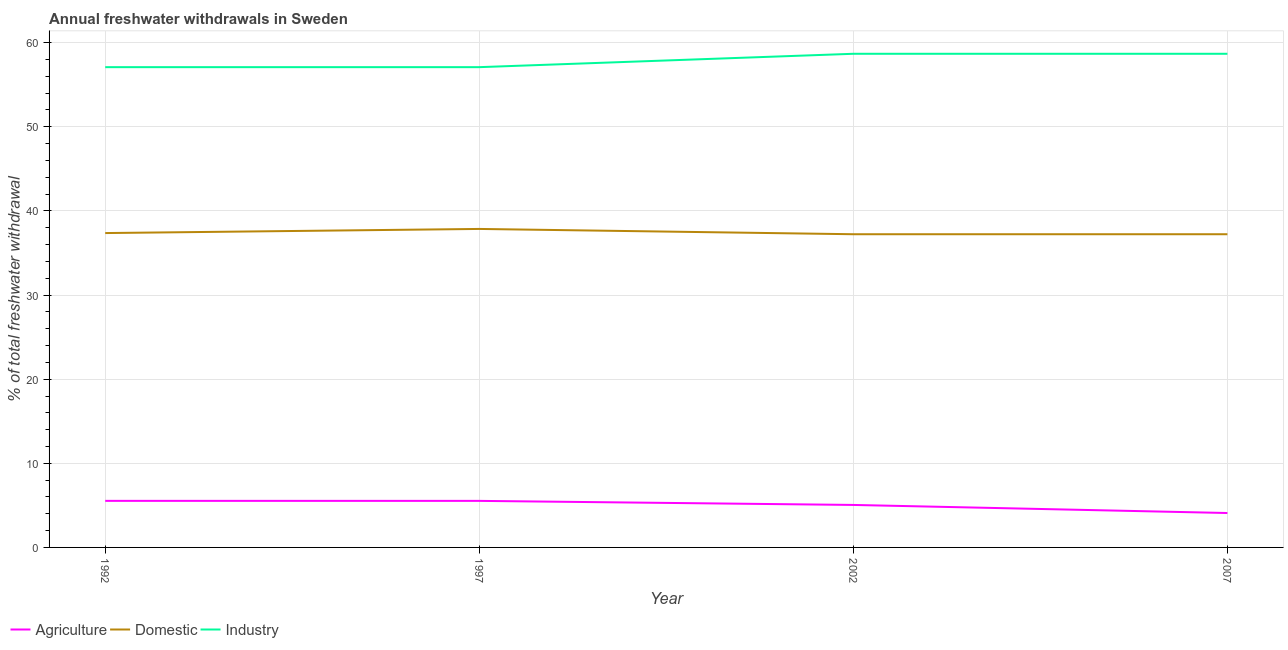How many different coloured lines are there?
Offer a very short reply. 3. Does the line corresponding to percentage of freshwater withdrawal for domestic purposes intersect with the line corresponding to percentage of freshwater withdrawal for industry?
Ensure brevity in your answer.  No. What is the percentage of freshwater withdrawal for agriculture in 1992?
Ensure brevity in your answer.  5.54. Across all years, what is the maximum percentage of freshwater withdrawal for domestic purposes?
Offer a very short reply. 37.86. Across all years, what is the minimum percentage of freshwater withdrawal for industry?
Your response must be concise. 57.09. In which year was the percentage of freshwater withdrawal for domestic purposes maximum?
Your response must be concise. 1997. What is the total percentage of freshwater withdrawal for industry in the graph?
Give a very brief answer. 231.54. What is the difference between the percentage of freshwater withdrawal for industry in 1992 and that in 2007?
Keep it short and to the point. -1.59. What is the difference between the percentage of freshwater withdrawal for industry in 2007 and the percentage of freshwater withdrawal for domestic purposes in 1992?
Your answer should be very brief. 21.31. What is the average percentage of freshwater withdrawal for domestic purposes per year?
Provide a short and direct response. 37.42. In the year 2002, what is the difference between the percentage of freshwater withdrawal for domestic purposes and percentage of freshwater withdrawal for agriculture?
Offer a very short reply. 32.18. What is the ratio of the percentage of freshwater withdrawal for agriculture in 1992 to that in 1997?
Your response must be concise. 1. What is the difference between the highest and the second highest percentage of freshwater withdrawal for domestic purposes?
Your answer should be very brief. 0.49. What is the difference between the highest and the lowest percentage of freshwater withdrawal for domestic purposes?
Your answer should be very brief. 0.63. Is the sum of the percentage of freshwater withdrawal for industry in 1992 and 1997 greater than the maximum percentage of freshwater withdrawal for agriculture across all years?
Your answer should be very brief. Yes. Does the percentage of freshwater withdrawal for domestic purposes monotonically increase over the years?
Ensure brevity in your answer.  No. Is the percentage of freshwater withdrawal for agriculture strictly greater than the percentage of freshwater withdrawal for industry over the years?
Provide a short and direct response. No. Is the percentage of freshwater withdrawal for agriculture strictly less than the percentage of freshwater withdrawal for domestic purposes over the years?
Provide a succinct answer. Yes. How many lines are there?
Give a very brief answer. 3. How many years are there in the graph?
Keep it short and to the point. 4. What is the difference between two consecutive major ticks on the Y-axis?
Make the answer very short. 10. Are the values on the major ticks of Y-axis written in scientific E-notation?
Your response must be concise. No. How many legend labels are there?
Provide a short and direct response. 3. How are the legend labels stacked?
Your response must be concise. Horizontal. What is the title of the graph?
Your answer should be compact. Annual freshwater withdrawals in Sweden. Does "Social Insurance" appear as one of the legend labels in the graph?
Keep it short and to the point. No. What is the label or title of the X-axis?
Ensure brevity in your answer.  Year. What is the label or title of the Y-axis?
Your answer should be compact. % of total freshwater withdrawal. What is the % of total freshwater withdrawal in Agriculture in 1992?
Your answer should be compact. 5.54. What is the % of total freshwater withdrawal of Domestic in 1992?
Your answer should be very brief. 37.37. What is the % of total freshwater withdrawal of Industry in 1992?
Make the answer very short. 57.09. What is the % of total freshwater withdrawal of Agriculture in 1997?
Your answer should be very brief. 5.53. What is the % of total freshwater withdrawal of Domestic in 1997?
Your response must be concise. 37.86. What is the % of total freshwater withdrawal in Industry in 1997?
Offer a terse response. 57.09. What is the % of total freshwater withdrawal of Agriculture in 2002?
Make the answer very short. 5.05. What is the % of total freshwater withdrawal of Domestic in 2002?
Your answer should be compact. 37.23. What is the % of total freshwater withdrawal of Industry in 2002?
Your response must be concise. 58.68. What is the % of total freshwater withdrawal of Agriculture in 2007?
Keep it short and to the point. 4.09. What is the % of total freshwater withdrawal in Domestic in 2007?
Keep it short and to the point. 37.23. What is the % of total freshwater withdrawal in Industry in 2007?
Offer a very short reply. 58.68. Across all years, what is the maximum % of total freshwater withdrawal in Agriculture?
Provide a succinct answer. 5.54. Across all years, what is the maximum % of total freshwater withdrawal of Domestic?
Offer a terse response. 37.86. Across all years, what is the maximum % of total freshwater withdrawal in Industry?
Ensure brevity in your answer.  58.68. Across all years, what is the minimum % of total freshwater withdrawal in Agriculture?
Provide a short and direct response. 4.09. Across all years, what is the minimum % of total freshwater withdrawal of Domestic?
Offer a very short reply. 37.23. Across all years, what is the minimum % of total freshwater withdrawal in Industry?
Keep it short and to the point. 57.09. What is the total % of total freshwater withdrawal in Agriculture in the graph?
Provide a short and direct response. 20.21. What is the total % of total freshwater withdrawal in Domestic in the graph?
Offer a very short reply. 149.69. What is the total % of total freshwater withdrawal in Industry in the graph?
Offer a terse response. 231.54. What is the difference between the % of total freshwater withdrawal of Agriculture in 1992 and that in 1997?
Provide a succinct answer. 0. What is the difference between the % of total freshwater withdrawal in Domestic in 1992 and that in 1997?
Provide a short and direct response. -0.49. What is the difference between the % of total freshwater withdrawal in Industry in 1992 and that in 1997?
Provide a succinct answer. 0. What is the difference between the % of total freshwater withdrawal in Agriculture in 1992 and that in 2002?
Your answer should be compact. 0.48. What is the difference between the % of total freshwater withdrawal of Domestic in 1992 and that in 2002?
Offer a very short reply. 0.14. What is the difference between the % of total freshwater withdrawal of Industry in 1992 and that in 2002?
Keep it short and to the point. -1.59. What is the difference between the % of total freshwater withdrawal in Agriculture in 1992 and that in 2007?
Provide a succinct answer. 1.45. What is the difference between the % of total freshwater withdrawal in Domestic in 1992 and that in 2007?
Your answer should be compact. 0.14. What is the difference between the % of total freshwater withdrawal of Industry in 1992 and that in 2007?
Give a very brief answer. -1.59. What is the difference between the % of total freshwater withdrawal of Agriculture in 1997 and that in 2002?
Your answer should be very brief. 0.48. What is the difference between the % of total freshwater withdrawal in Domestic in 1997 and that in 2002?
Ensure brevity in your answer.  0.63. What is the difference between the % of total freshwater withdrawal of Industry in 1997 and that in 2002?
Give a very brief answer. -1.59. What is the difference between the % of total freshwater withdrawal of Agriculture in 1997 and that in 2007?
Provide a succinct answer. 1.44. What is the difference between the % of total freshwater withdrawal in Domestic in 1997 and that in 2007?
Your response must be concise. 0.63. What is the difference between the % of total freshwater withdrawal of Industry in 1997 and that in 2007?
Your response must be concise. -1.59. What is the difference between the % of total freshwater withdrawal of Agriculture in 2002 and that in 2007?
Ensure brevity in your answer.  0.96. What is the difference between the % of total freshwater withdrawal of Domestic in 2002 and that in 2007?
Provide a succinct answer. 0. What is the difference between the % of total freshwater withdrawal in Agriculture in 1992 and the % of total freshwater withdrawal in Domestic in 1997?
Keep it short and to the point. -32.32. What is the difference between the % of total freshwater withdrawal of Agriculture in 1992 and the % of total freshwater withdrawal of Industry in 1997?
Offer a terse response. -51.55. What is the difference between the % of total freshwater withdrawal of Domestic in 1992 and the % of total freshwater withdrawal of Industry in 1997?
Offer a terse response. -19.72. What is the difference between the % of total freshwater withdrawal in Agriculture in 1992 and the % of total freshwater withdrawal in Domestic in 2002?
Your answer should be compact. -31.69. What is the difference between the % of total freshwater withdrawal in Agriculture in 1992 and the % of total freshwater withdrawal in Industry in 2002?
Your response must be concise. -53.14. What is the difference between the % of total freshwater withdrawal in Domestic in 1992 and the % of total freshwater withdrawal in Industry in 2002?
Your response must be concise. -21.31. What is the difference between the % of total freshwater withdrawal in Agriculture in 1992 and the % of total freshwater withdrawal in Domestic in 2007?
Give a very brief answer. -31.69. What is the difference between the % of total freshwater withdrawal of Agriculture in 1992 and the % of total freshwater withdrawal of Industry in 2007?
Your response must be concise. -53.14. What is the difference between the % of total freshwater withdrawal of Domestic in 1992 and the % of total freshwater withdrawal of Industry in 2007?
Provide a succinct answer. -21.31. What is the difference between the % of total freshwater withdrawal of Agriculture in 1997 and the % of total freshwater withdrawal of Domestic in 2002?
Offer a terse response. -31.7. What is the difference between the % of total freshwater withdrawal of Agriculture in 1997 and the % of total freshwater withdrawal of Industry in 2002?
Your answer should be compact. -53.15. What is the difference between the % of total freshwater withdrawal in Domestic in 1997 and the % of total freshwater withdrawal in Industry in 2002?
Your answer should be compact. -20.82. What is the difference between the % of total freshwater withdrawal in Agriculture in 1997 and the % of total freshwater withdrawal in Domestic in 2007?
Give a very brief answer. -31.7. What is the difference between the % of total freshwater withdrawal in Agriculture in 1997 and the % of total freshwater withdrawal in Industry in 2007?
Offer a terse response. -53.15. What is the difference between the % of total freshwater withdrawal in Domestic in 1997 and the % of total freshwater withdrawal in Industry in 2007?
Your answer should be very brief. -20.82. What is the difference between the % of total freshwater withdrawal of Agriculture in 2002 and the % of total freshwater withdrawal of Domestic in 2007?
Your answer should be very brief. -32.18. What is the difference between the % of total freshwater withdrawal of Agriculture in 2002 and the % of total freshwater withdrawal of Industry in 2007?
Your answer should be very brief. -53.63. What is the difference between the % of total freshwater withdrawal in Domestic in 2002 and the % of total freshwater withdrawal in Industry in 2007?
Keep it short and to the point. -21.45. What is the average % of total freshwater withdrawal in Agriculture per year?
Your response must be concise. 5.05. What is the average % of total freshwater withdrawal in Domestic per year?
Keep it short and to the point. 37.42. What is the average % of total freshwater withdrawal of Industry per year?
Give a very brief answer. 57.88. In the year 1992, what is the difference between the % of total freshwater withdrawal in Agriculture and % of total freshwater withdrawal in Domestic?
Ensure brevity in your answer.  -31.83. In the year 1992, what is the difference between the % of total freshwater withdrawal of Agriculture and % of total freshwater withdrawal of Industry?
Make the answer very short. -51.55. In the year 1992, what is the difference between the % of total freshwater withdrawal in Domestic and % of total freshwater withdrawal in Industry?
Provide a short and direct response. -19.72. In the year 1997, what is the difference between the % of total freshwater withdrawal in Agriculture and % of total freshwater withdrawal in Domestic?
Your response must be concise. -32.33. In the year 1997, what is the difference between the % of total freshwater withdrawal of Agriculture and % of total freshwater withdrawal of Industry?
Make the answer very short. -51.56. In the year 1997, what is the difference between the % of total freshwater withdrawal of Domestic and % of total freshwater withdrawal of Industry?
Your answer should be compact. -19.23. In the year 2002, what is the difference between the % of total freshwater withdrawal of Agriculture and % of total freshwater withdrawal of Domestic?
Make the answer very short. -32.18. In the year 2002, what is the difference between the % of total freshwater withdrawal of Agriculture and % of total freshwater withdrawal of Industry?
Your response must be concise. -53.63. In the year 2002, what is the difference between the % of total freshwater withdrawal in Domestic and % of total freshwater withdrawal in Industry?
Give a very brief answer. -21.45. In the year 2007, what is the difference between the % of total freshwater withdrawal in Agriculture and % of total freshwater withdrawal in Domestic?
Your answer should be very brief. -33.14. In the year 2007, what is the difference between the % of total freshwater withdrawal in Agriculture and % of total freshwater withdrawal in Industry?
Offer a terse response. -54.59. In the year 2007, what is the difference between the % of total freshwater withdrawal in Domestic and % of total freshwater withdrawal in Industry?
Offer a very short reply. -21.45. What is the ratio of the % of total freshwater withdrawal of Domestic in 1992 to that in 1997?
Your answer should be compact. 0.99. What is the ratio of the % of total freshwater withdrawal in Industry in 1992 to that in 1997?
Provide a succinct answer. 1. What is the ratio of the % of total freshwater withdrawal of Agriculture in 1992 to that in 2002?
Provide a succinct answer. 1.1. What is the ratio of the % of total freshwater withdrawal of Domestic in 1992 to that in 2002?
Keep it short and to the point. 1. What is the ratio of the % of total freshwater withdrawal of Industry in 1992 to that in 2002?
Offer a very short reply. 0.97. What is the ratio of the % of total freshwater withdrawal in Agriculture in 1992 to that in 2007?
Give a very brief answer. 1.35. What is the ratio of the % of total freshwater withdrawal in Domestic in 1992 to that in 2007?
Ensure brevity in your answer.  1. What is the ratio of the % of total freshwater withdrawal of Industry in 1992 to that in 2007?
Your answer should be compact. 0.97. What is the ratio of the % of total freshwater withdrawal of Agriculture in 1997 to that in 2002?
Make the answer very short. 1.1. What is the ratio of the % of total freshwater withdrawal in Domestic in 1997 to that in 2002?
Your response must be concise. 1.02. What is the ratio of the % of total freshwater withdrawal in Industry in 1997 to that in 2002?
Provide a succinct answer. 0.97. What is the ratio of the % of total freshwater withdrawal in Agriculture in 1997 to that in 2007?
Offer a terse response. 1.35. What is the ratio of the % of total freshwater withdrawal of Domestic in 1997 to that in 2007?
Keep it short and to the point. 1.02. What is the ratio of the % of total freshwater withdrawal in Industry in 1997 to that in 2007?
Keep it short and to the point. 0.97. What is the ratio of the % of total freshwater withdrawal of Agriculture in 2002 to that in 2007?
Give a very brief answer. 1.24. What is the difference between the highest and the second highest % of total freshwater withdrawal in Agriculture?
Give a very brief answer. 0. What is the difference between the highest and the second highest % of total freshwater withdrawal of Domestic?
Provide a succinct answer. 0.49. What is the difference between the highest and the lowest % of total freshwater withdrawal in Agriculture?
Give a very brief answer. 1.45. What is the difference between the highest and the lowest % of total freshwater withdrawal in Domestic?
Make the answer very short. 0.63. What is the difference between the highest and the lowest % of total freshwater withdrawal of Industry?
Your answer should be compact. 1.59. 